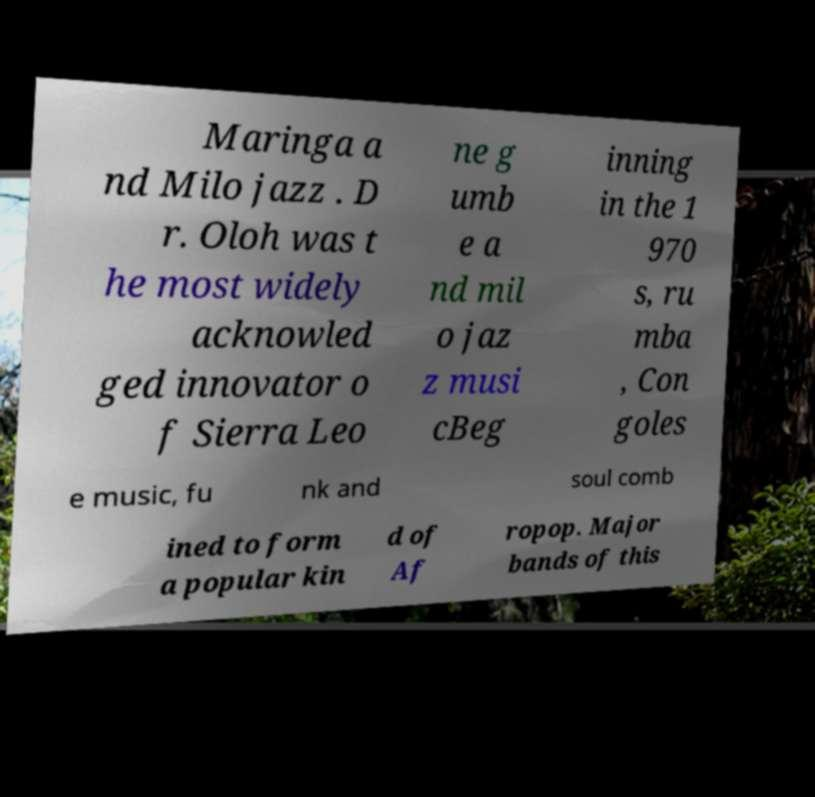Please identify and transcribe the text found in this image. Maringa a nd Milo jazz . D r. Oloh was t he most widely acknowled ged innovator o f Sierra Leo ne g umb e a nd mil o jaz z musi cBeg inning in the 1 970 s, ru mba , Con goles e music, fu nk and soul comb ined to form a popular kin d of Af ropop. Major bands of this 